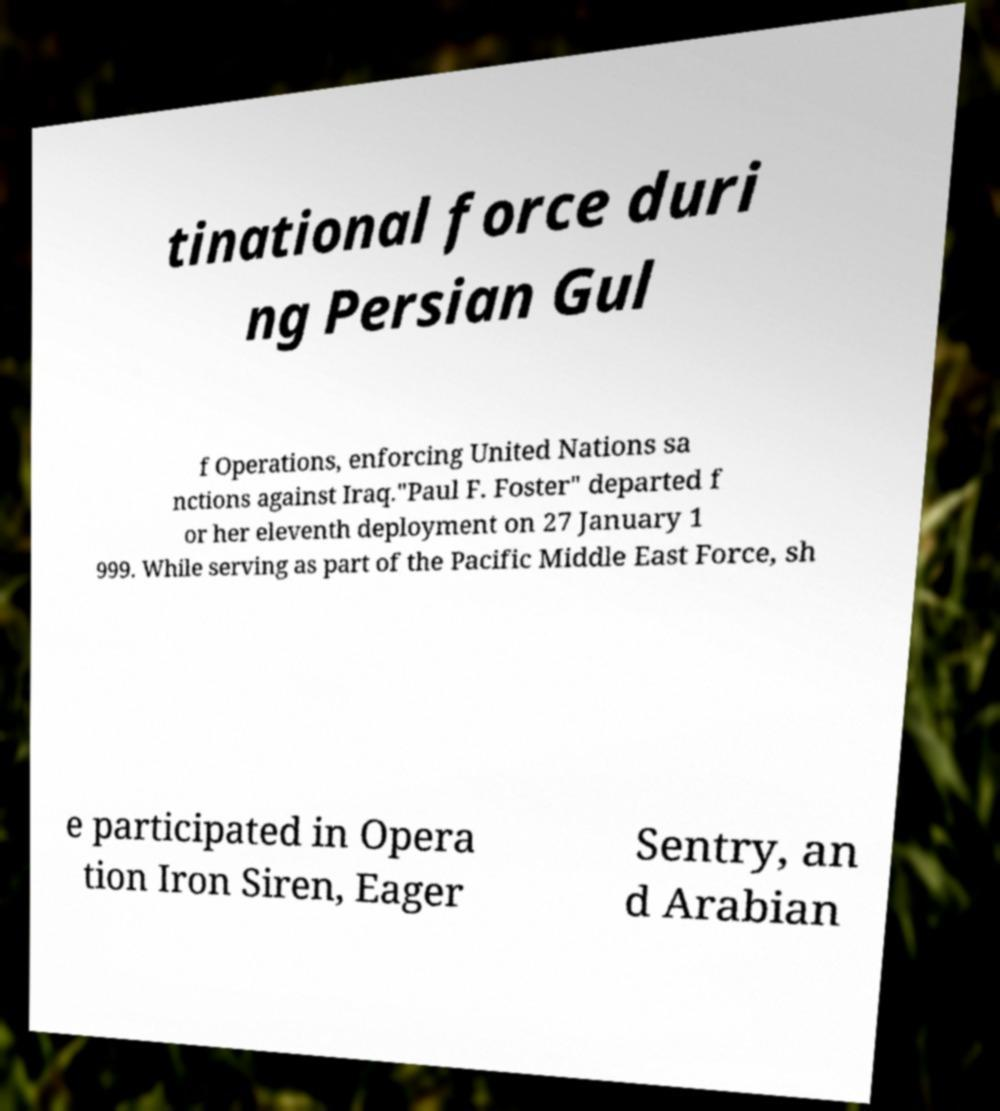Please read and relay the text visible in this image. What does it say? tinational force duri ng Persian Gul f Operations, enforcing United Nations sa nctions against Iraq."Paul F. Foster" departed f or her eleventh deployment on 27 January 1 999. While serving as part of the Pacific Middle East Force, sh e participated in Opera tion Iron Siren, Eager Sentry, an d Arabian 